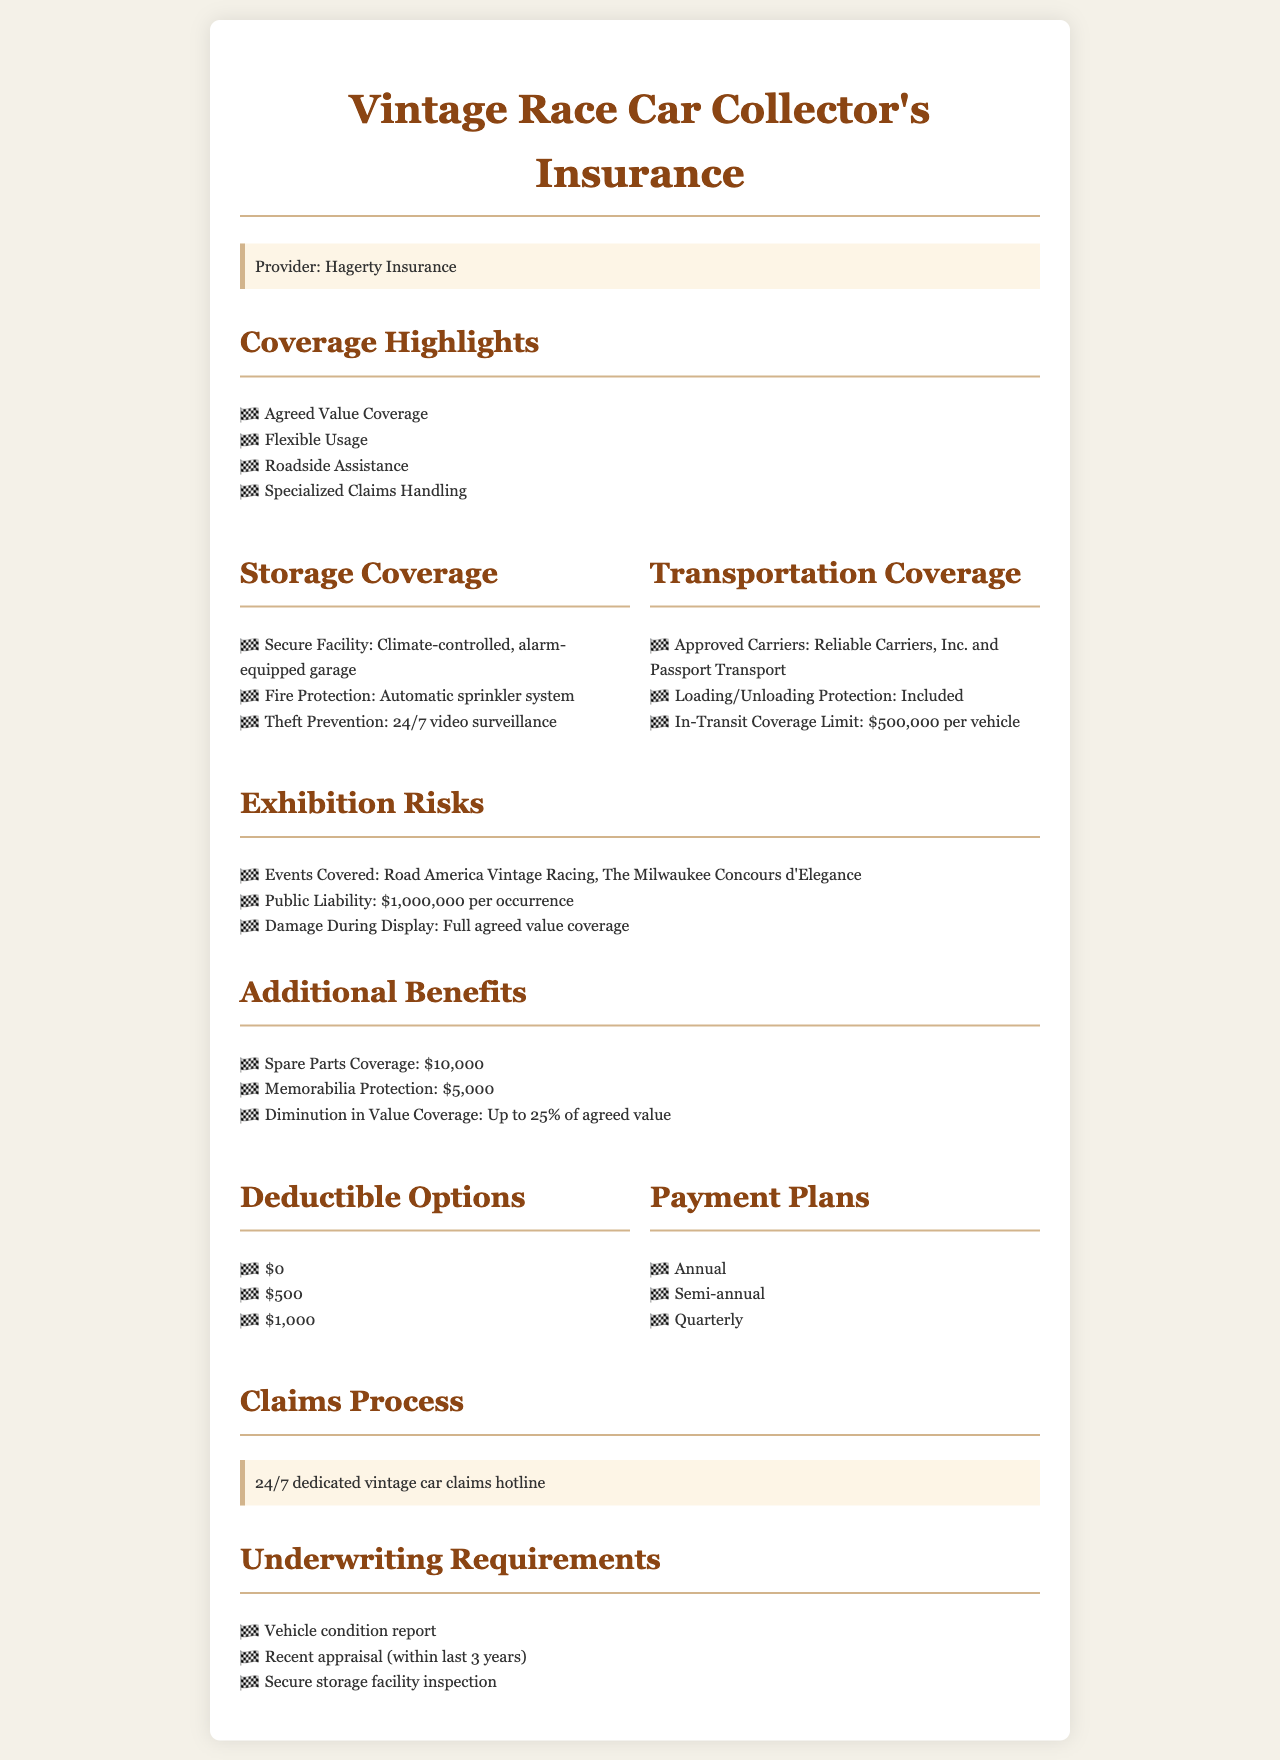What is the provider of the insurance? The document states that the provider of the insurance is Hagerty Insurance.
Answer: Hagerty Insurance What is the in-transit coverage limit per vehicle? The document specifies that the in-transit coverage limit is $500,000 per vehicle.
Answer: $500,000 Which events are covered under exhibition risks? The document lists Road America Vintage Racing and The Milwaukee Concours d'Elegance as the events covered.
Answer: Road America Vintage Racing, The Milwaukee Concours d'Elegance What is the public liability coverage per occurrence? According to the document, the public liability coverage is $1,000,000 per occurrence.
Answer: $1,000,000 What is the amount for spare parts coverage? The document states that the spare parts coverage amount is $10,000.
Answer: $10,000 What are the deductible options mentioned? The deductible options listed in the document are $0, $500, and $1,000.
Answer: $0, $500, $1,000 What type of report is required for underwriting? The document mentions that a vehicle condition report is required for underwriting.
Answer: Vehicle condition report What support is available for claims processing? The document provides a 24/7 dedicated vintage car claims hotline for claims processing.
Answer: 24/7 dedicated vintage car claims hotline What is included in the theft prevention measures during storage? The document states that theft prevention includes 24/7 video surveillance.
Answer: 24/7 video surveillance 